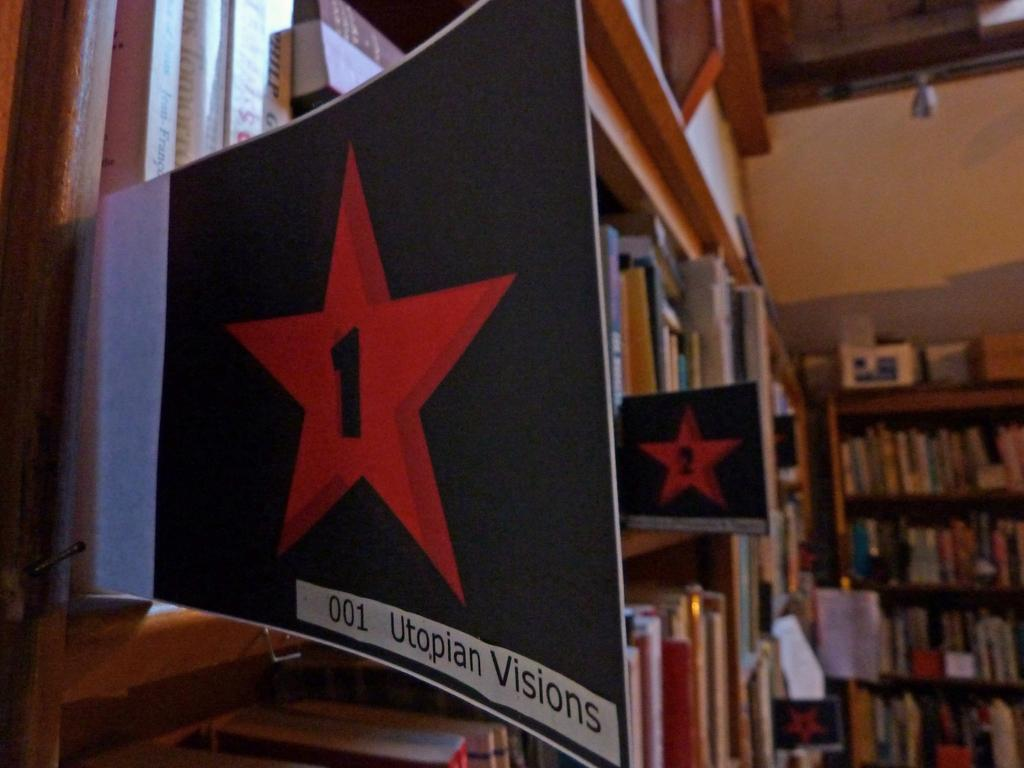<image>
Give a short and clear explanation of the subsequent image. A shelf talker with a red star advertises Utopian Visions books. 